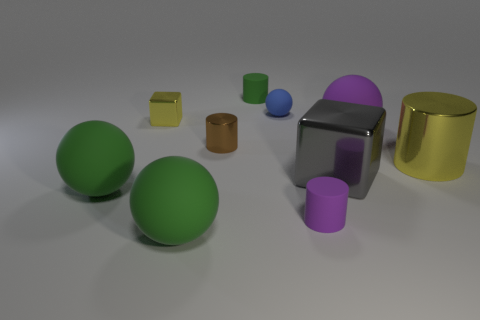There is a sphere behind the purple sphere; does it have the same color as the cylinder in front of the large gray metal block? no 